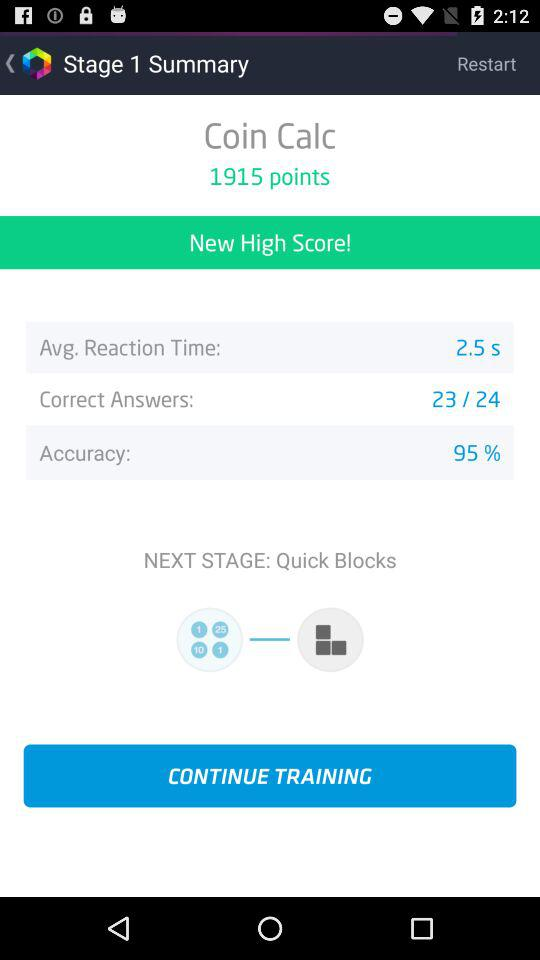How many total questions are there? There are 24 questions in total. 